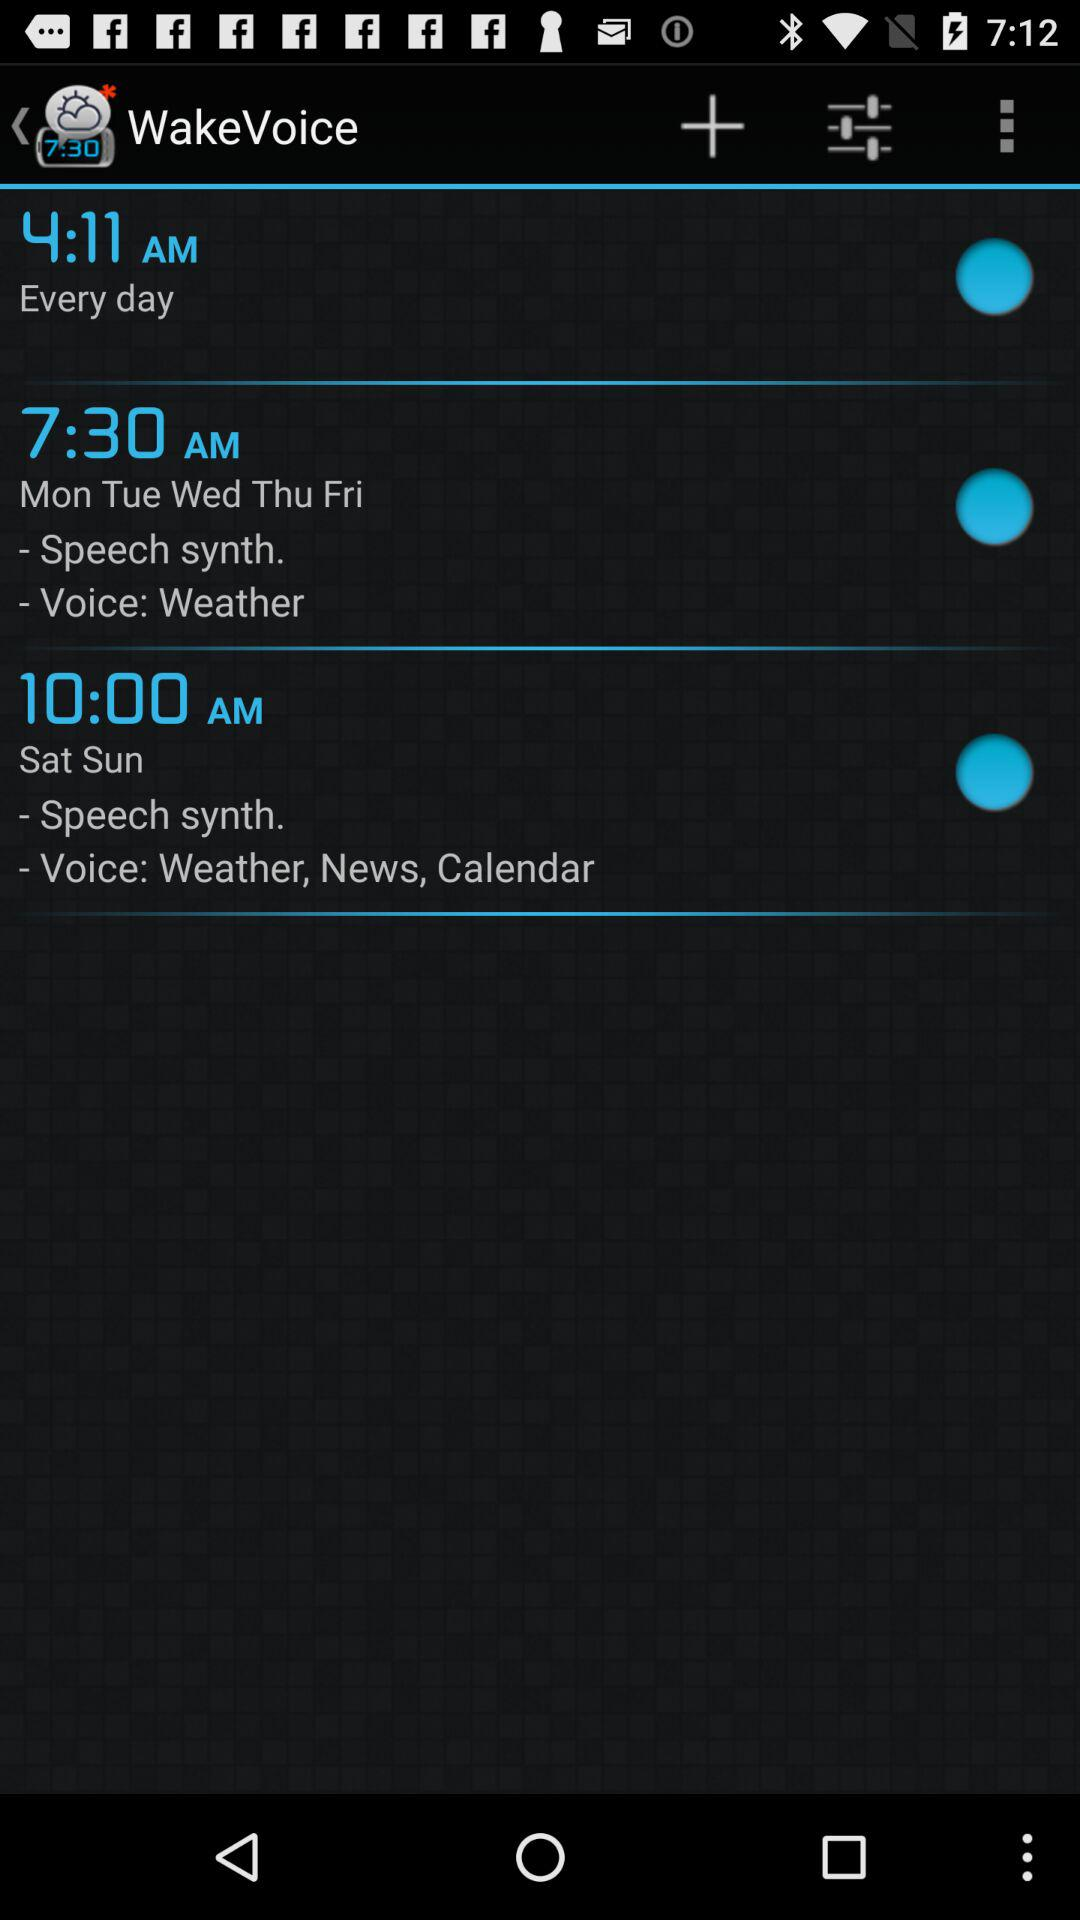On which days is the 7:30 a.m. wake voice set? The days are Monday, Tuesday, Wednesday, Thursday and Friday. 